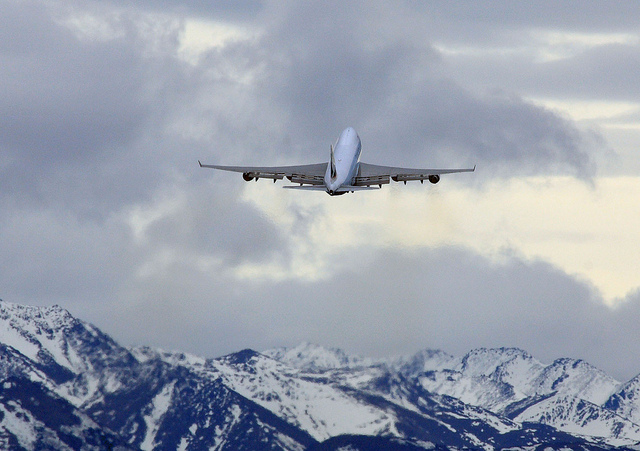Can you tell what time of day it might be? Based on the image, it's difficult to ascertain the exact time of day. However, the lighting suggests it could be either late afternoon or early morning, considering the softness of the light and the lack of strong shadows. 